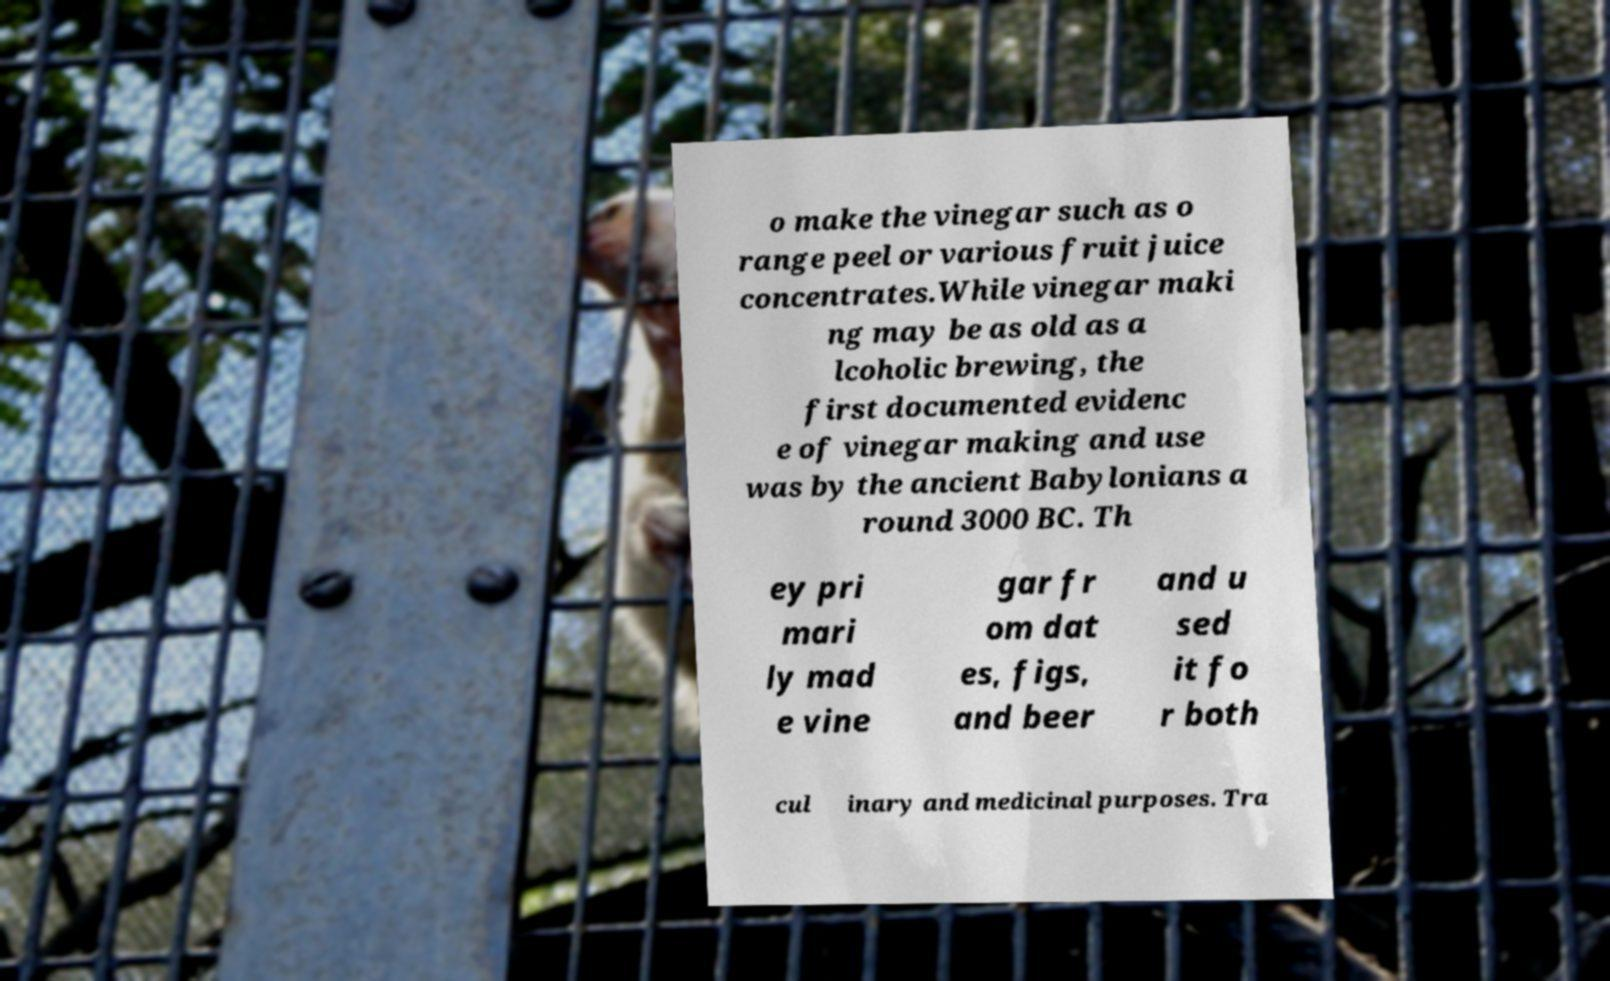Could you assist in decoding the text presented in this image and type it out clearly? o make the vinegar such as o range peel or various fruit juice concentrates.While vinegar maki ng may be as old as a lcoholic brewing, the first documented evidenc e of vinegar making and use was by the ancient Babylonians a round 3000 BC. Th ey pri mari ly mad e vine gar fr om dat es, figs, and beer and u sed it fo r both cul inary and medicinal purposes. Tra 